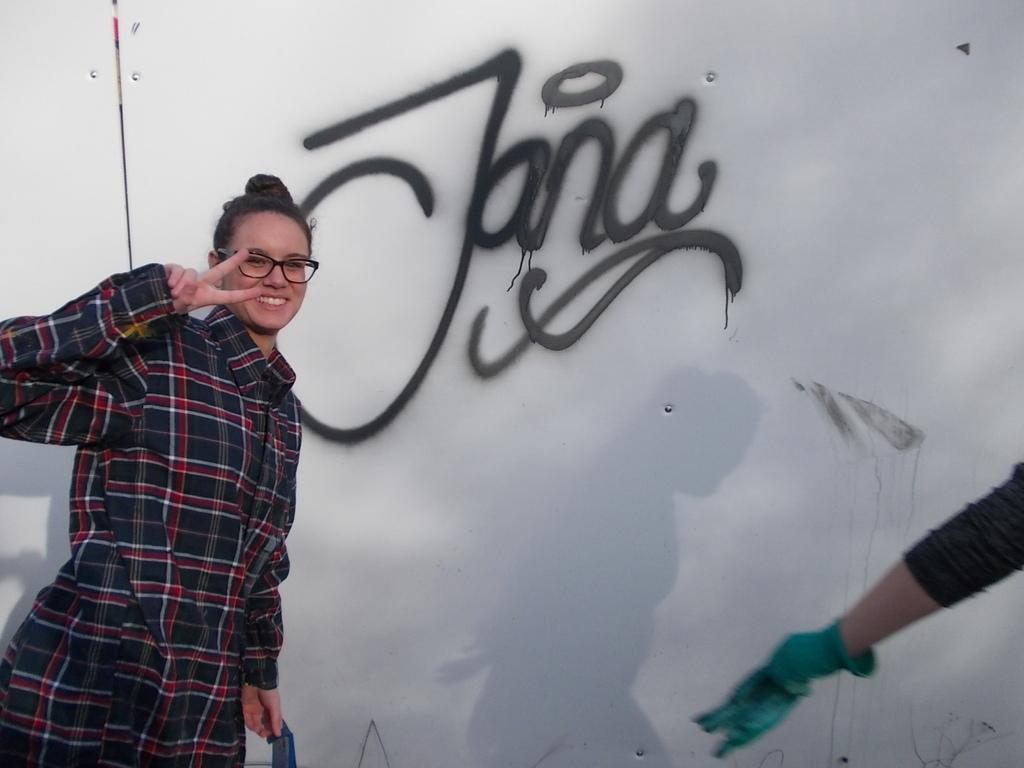How would you summarize this image in a sentence or two? In this picture we can see a woman, behind we can see painted wall. 